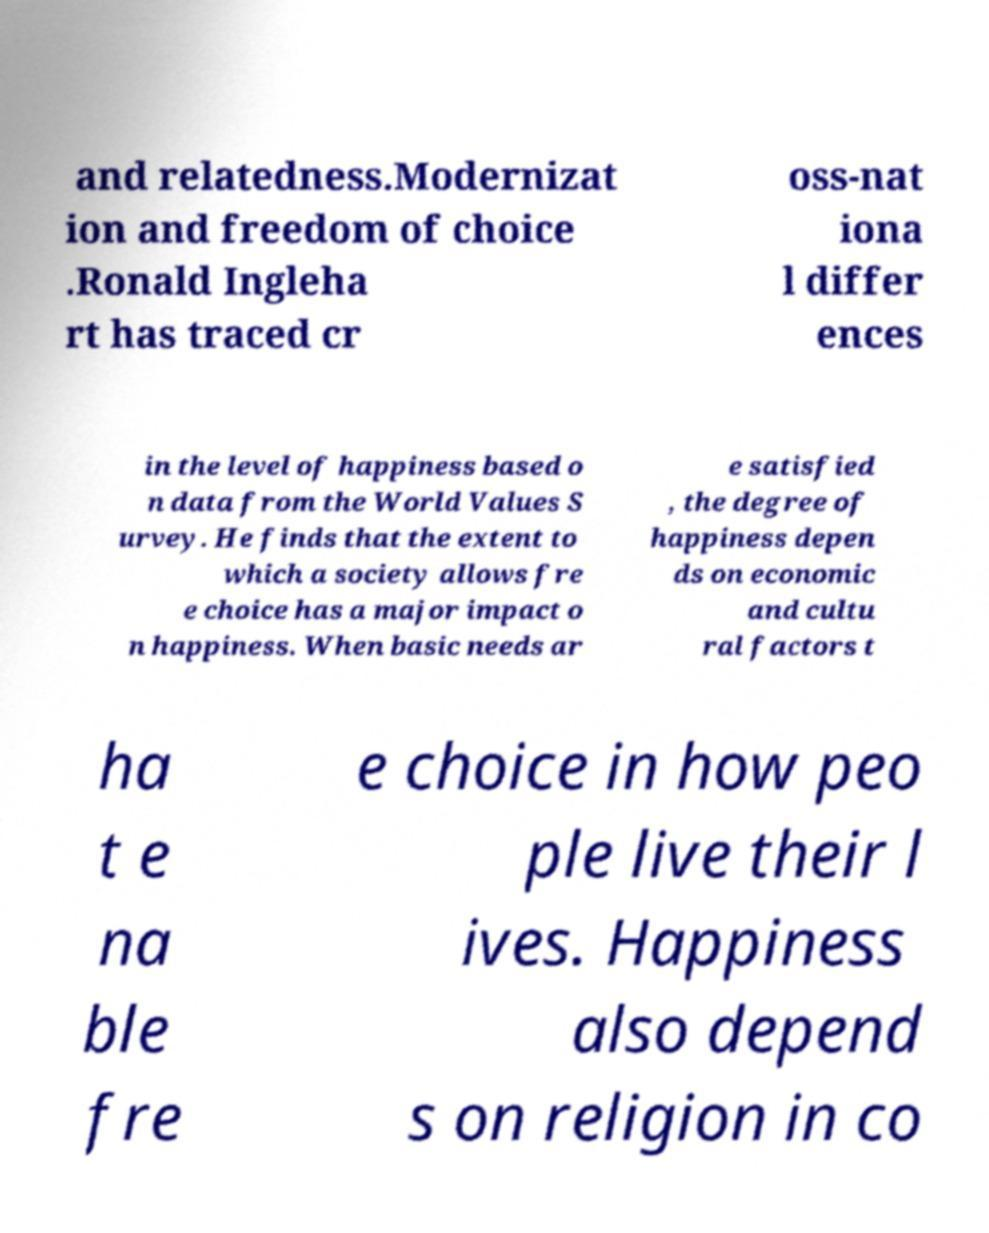What messages or text are displayed in this image? I need them in a readable, typed format. and relatedness.Modernizat ion and freedom of choice .Ronald Ingleha rt has traced cr oss-nat iona l differ ences in the level of happiness based o n data from the World Values S urvey. He finds that the extent to which a society allows fre e choice has a major impact o n happiness. When basic needs ar e satisfied , the degree of happiness depen ds on economic and cultu ral factors t ha t e na ble fre e choice in how peo ple live their l ives. Happiness also depend s on religion in co 